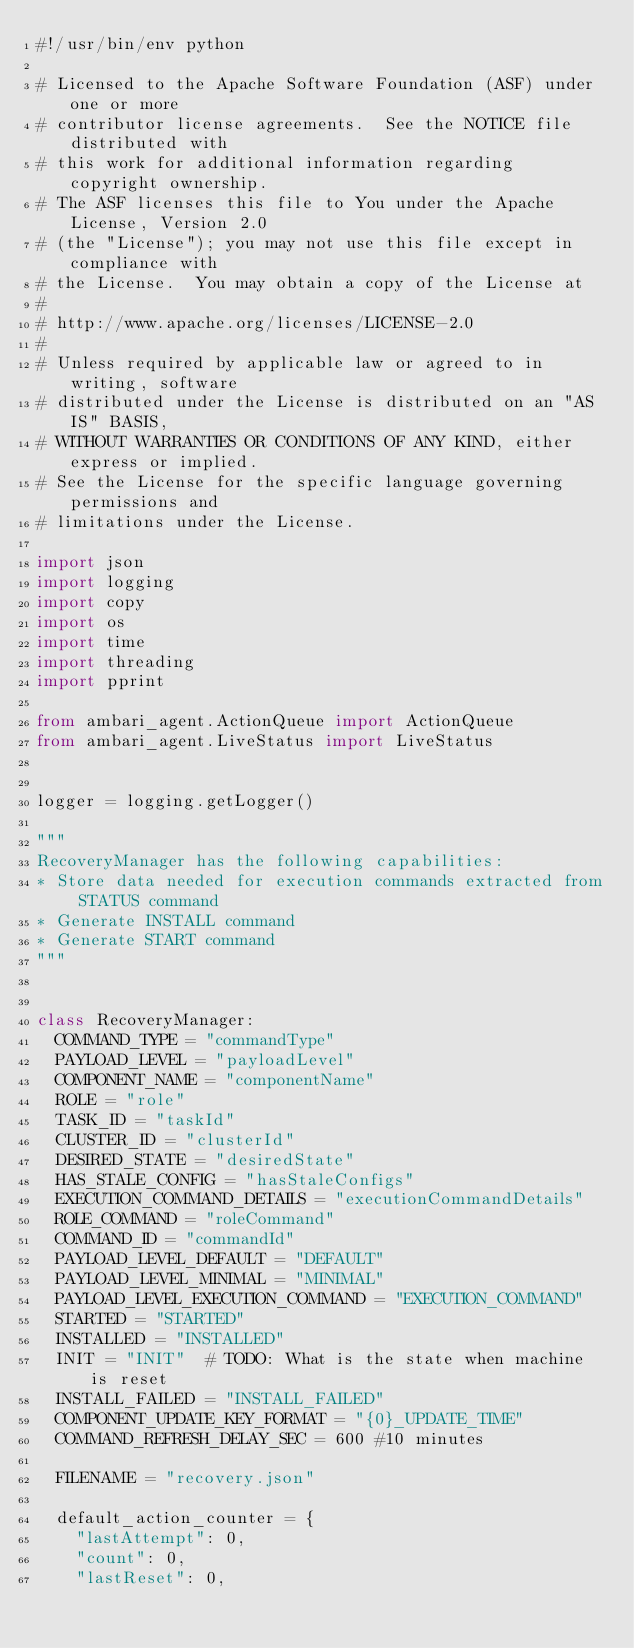Convert code to text. <code><loc_0><loc_0><loc_500><loc_500><_Python_>#!/usr/bin/env python

# Licensed to the Apache Software Foundation (ASF) under one or more
# contributor license agreements.  See the NOTICE file distributed with
# this work for additional information regarding copyright ownership.
# The ASF licenses this file to You under the Apache License, Version 2.0
# (the "License"); you may not use this file except in compliance with
# the License.  You may obtain a copy of the License at
#
# http://www.apache.org/licenses/LICENSE-2.0
#
# Unless required by applicable law or agreed to in writing, software
# distributed under the License is distributed on an "AS IS" BASIS,
# WITHOUT WARRANTIES OR CONDITIONS OF ANY KIND, either express or implied.
# See the License for the specific language governing permissions and
# limitations under the License.

import json
import logging
import copy
import os
import time
import threading
import pprint

from ambari_agent.ActionQueue import ActionQueue
from ambari_agent.LiveStatus import LiveStatus


logger = logging.getLogger()

"""
RecoveryManager has the following capabilities:
* Store data needed for execution commands extracted from STATUS command
* Generate INSTALL command
* Generate START command
"""


class RecoveryManager:
  COMMAND_TYPE = "commandType"
  PAYLOAD_LEVEL = "payloadLevel"
  COMPONENT_NAME = "componentName"
  ROLE = "role"
  TASK_ID = "taskId"
  CLUSTER_ID = "clusterId"
  DESIRED_STATE = "desiredState"
  HAS_STALE_CONFIG = "hasStaleConfigs"
  EXECUTION_COMMAND_DETAILS = "executionCommandDetails"
  ROLE_COMMAND = "roleCommand"
  COMMAND_ID = "commandId"
  PAYLOAD_LEVEL_DEFAULT = "DEFAULT"
  PAYLOAD_LEVEL_MINIMAL = "MINIMAL"
  PAYLOAD_LEVEL_EXECUTION_COMMAND = "EXECUTION_COMMAND"
  STARTED = "STARTED"
  INSTALLED = "INSTALLED"
  INIT = "INIT"  # TODO: What is the state when machine is reset
  INSTALL_FAILED = "INSTALL_FAILED"
  COMPONENT_UPDATE_KEY_FORMAT = "{0}_UPDATE_TIME"
  COMMAND_REFRESH_DELAY_SEC = 600 #10 minutes

  FILENAME = "recovery.json"

  default_action_counter = {
    "lastAttempt": 0,
    "count": 0,
    "lastReset": 0,</code> 